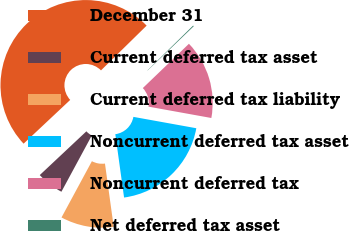Convert chart. <chart><loc_0><loc_0><loc_500><loc_500><pie_chart><fcel>December 31<fcel>Current deferred tax asset<fcel>Current deferred tax liability<fcel>Noncurrent deferred tax asset<fcel>Noncurrent deferred tax<fcel>Net deferred tax asset<nl><fcel>49.65%<fcel>5.12%<fcel>10.07%<fcel>19.97%<fcel>15.02%<fcel>0.17%<nl></chart> 